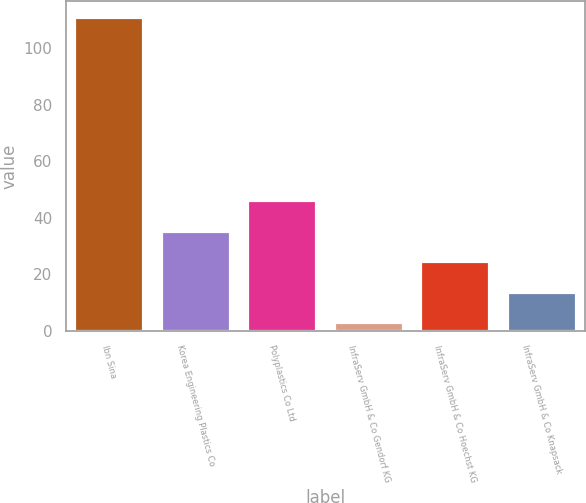<chart> <loc_0><loc_0><loc_500><loc_500><bar_chart><fcel>Ibn Sina<fcel>Korea Engineering Plastics Co<fcel>Polyplastics Co Ltd<fcel>InfraServ GmbH & Co Gendorf KG<fcel>InfraServ GmbH & Co Hoechst KG<fcel>InfraServ GmbH & Co Knapsack<nl><fcel>111<fcel>35.4<fcel>46.2<fcel>3<fcel>24.6<fcel>13.8<nl></chart> 